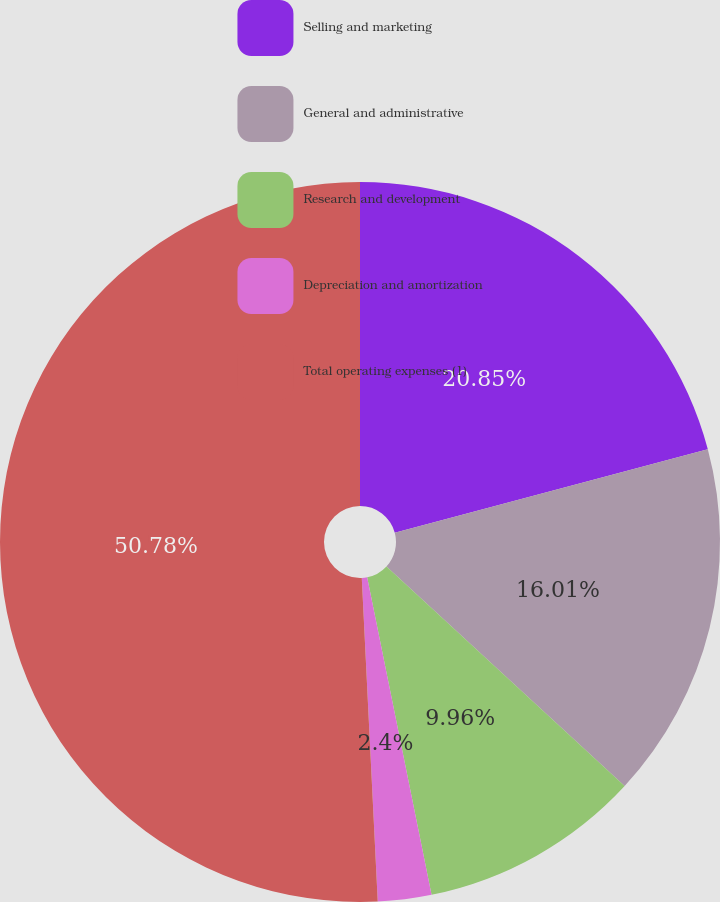<chart> <loc_0><loc_0><loc_500><loc_500><pie_chart><fcel>Selling and marketing<fcel>General and administrative<fcel>Research and development<fcel>Depreciation and amortization<fcel>Total operating expenses (1)<nl><fcel>20.85%<fcel>16.01%<fcel>9.96%<fcel>2.4%<fcel>50.79%<nl></chart> 